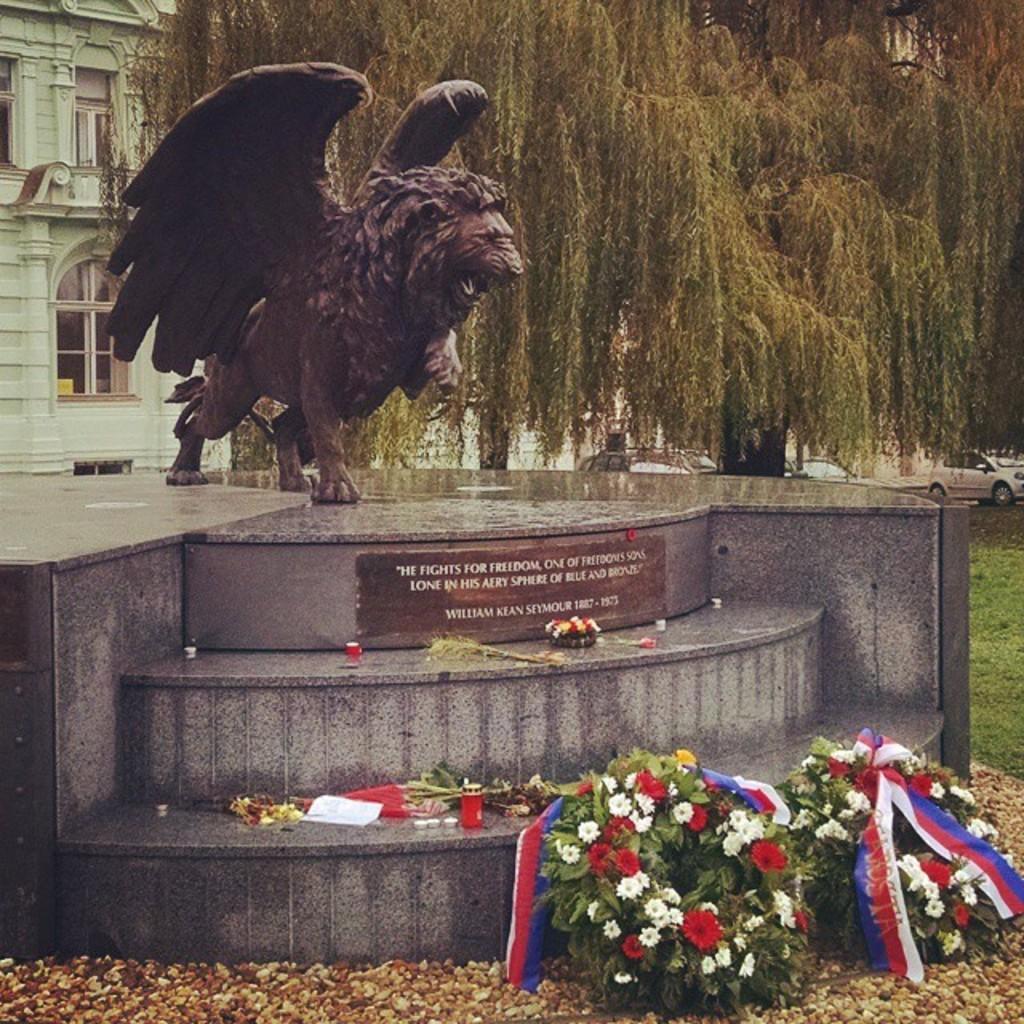Please provide a concise description of this image. In the foreground of the picture I can see the statue of a lion. I can see the flower bouquets on the floor on the bottom right side of the picture. In the background, I can see the building, trees and cars. I can see the green grass on the right side. 